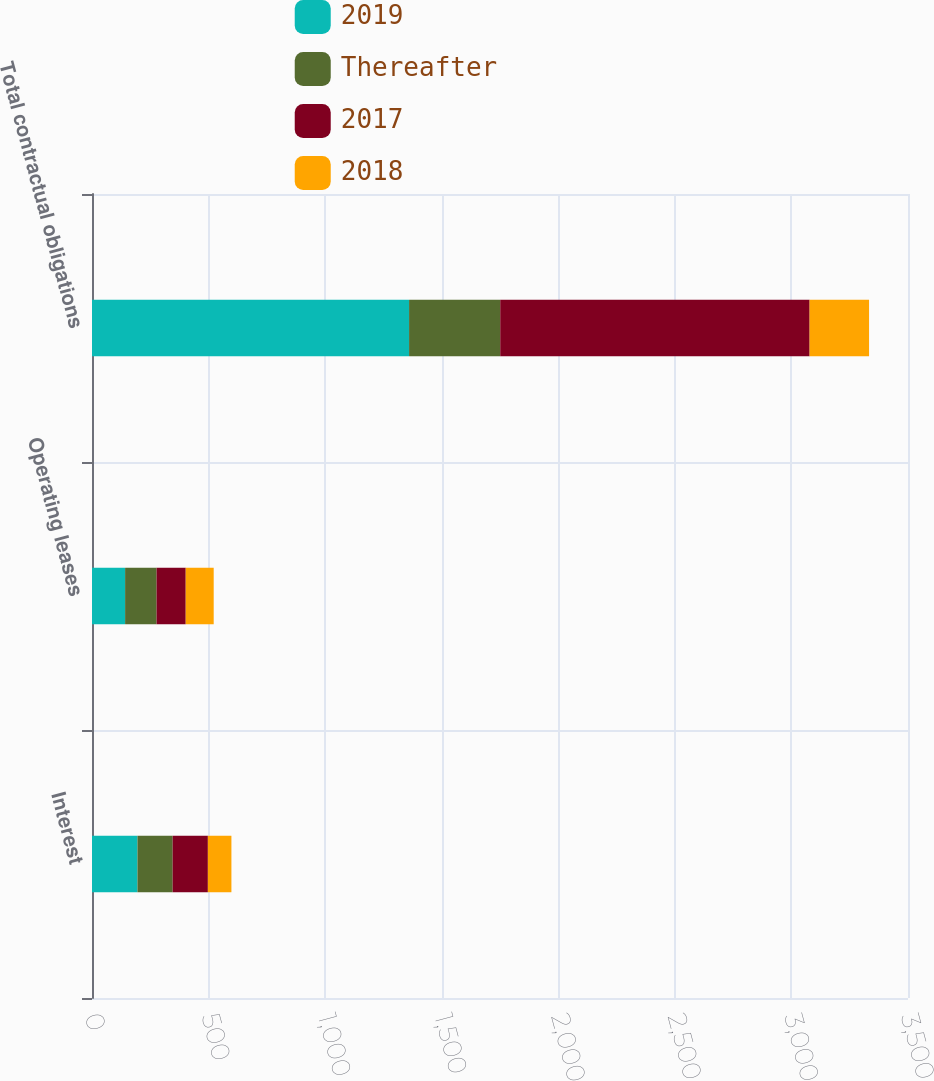Convert chart to OTSL. <chart><loc_0><loc_0><loc_500><loc_500><stacked_bar_chart><ecel><fcel>Interest<fcel>Operating leases<fcel>Total contractual obligations<nl><fcel>2019<fcel>195<fcel>142<fcel>1360<nl><fcel>Thereafter<fcel>151<fcel>135<fcel>391<nl><fcel>2017<fcel>151<fcel>125<fcel>1327<nl><fcel>2018<fcel>101<fcel>120<fcel>255<nl></chart> 